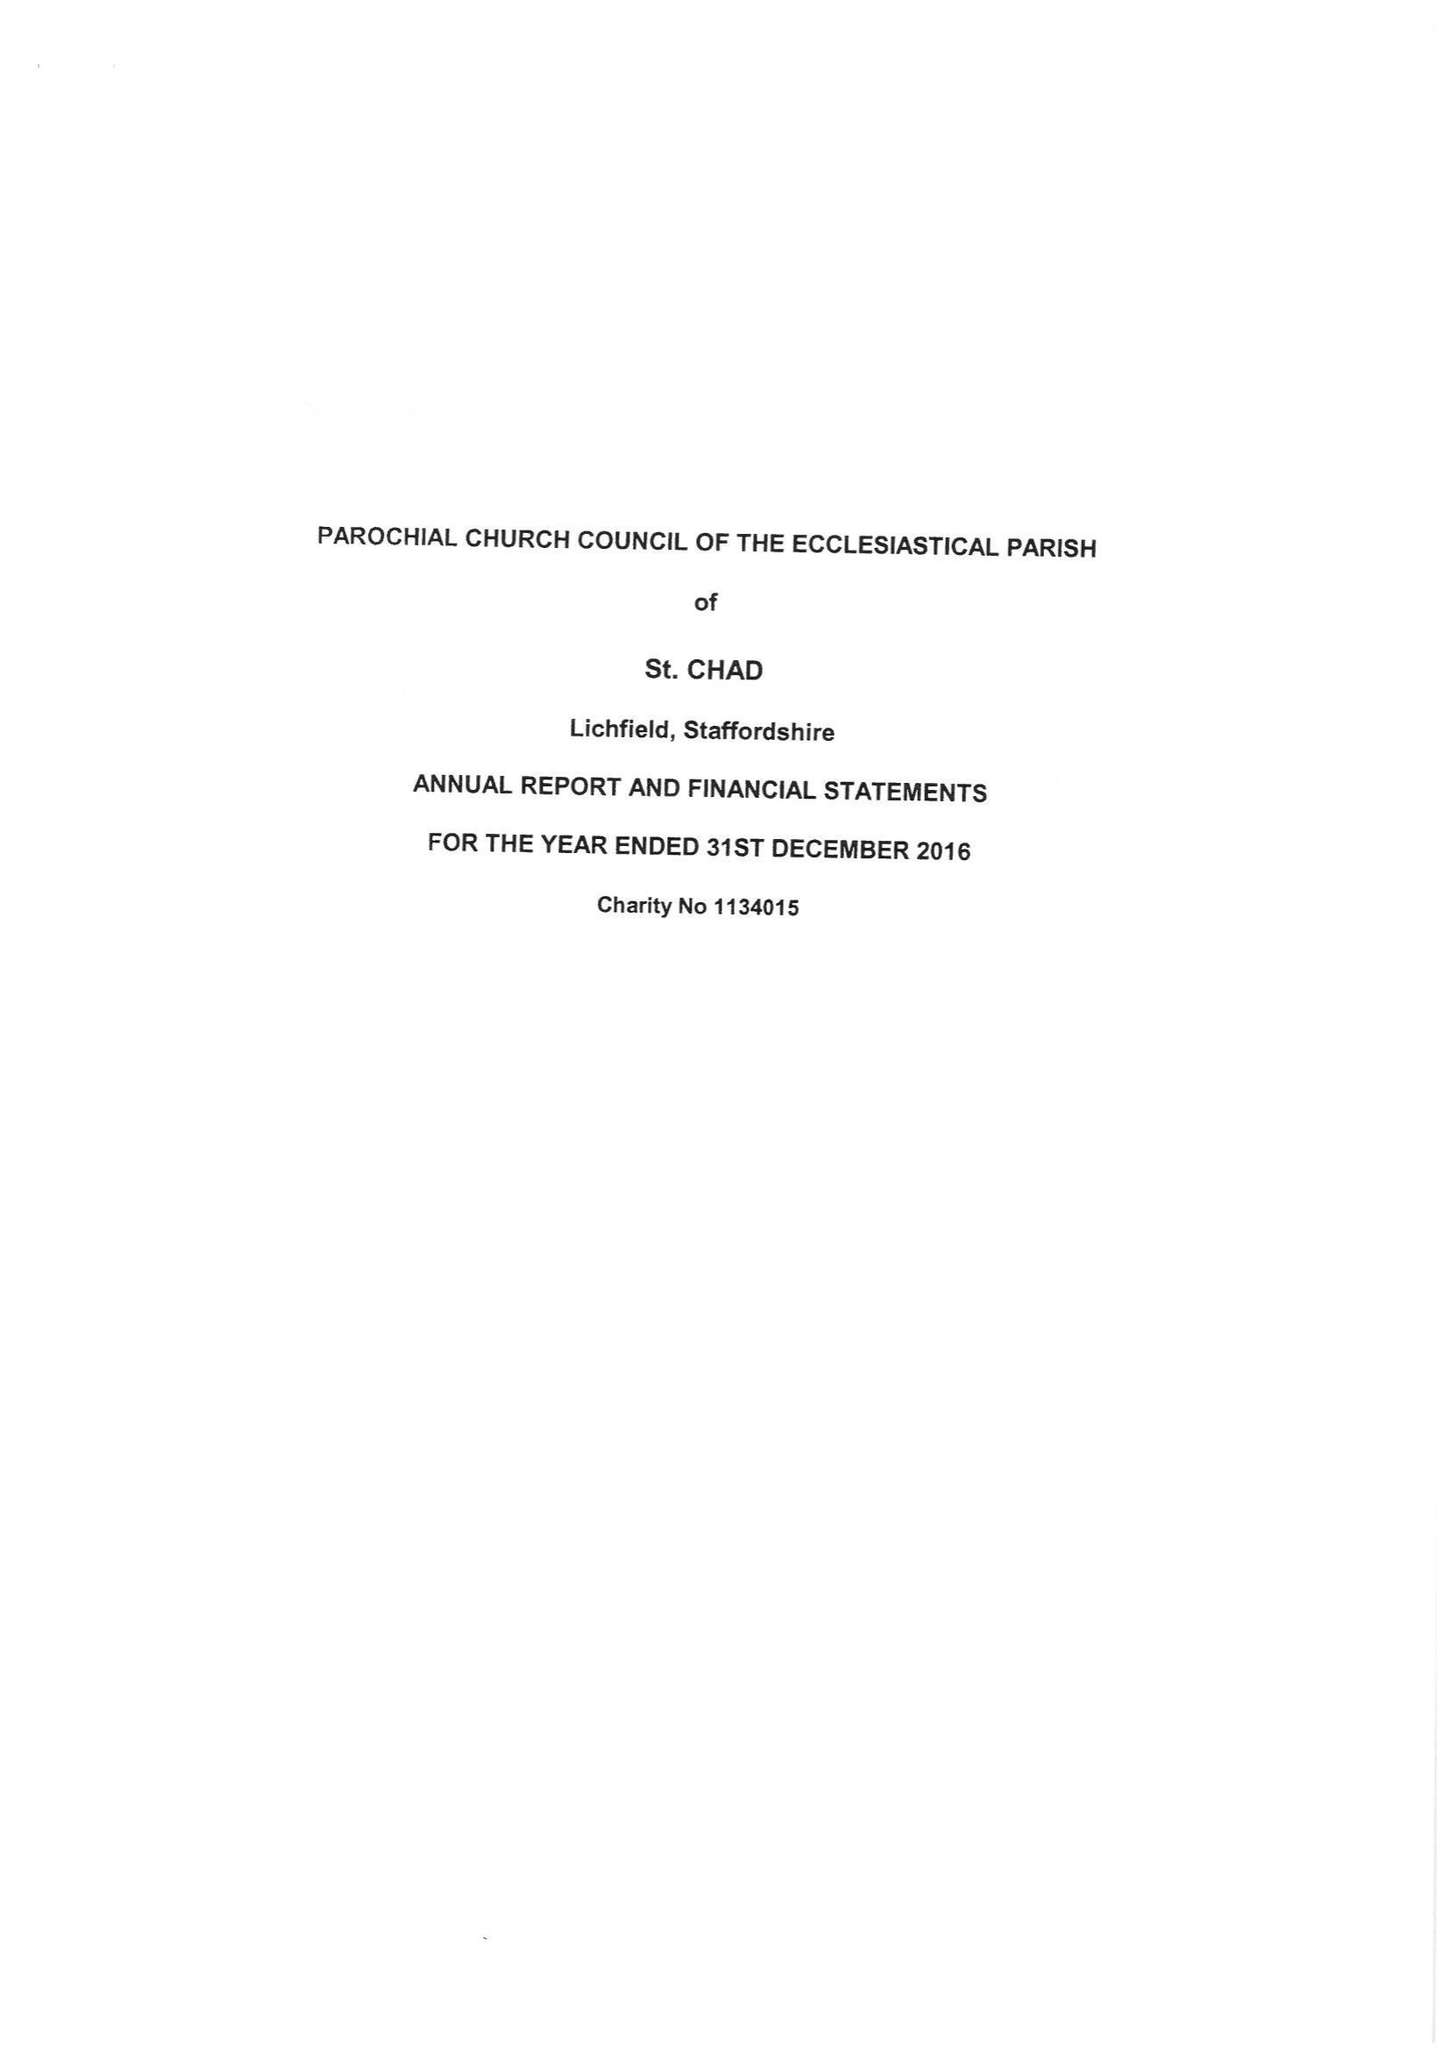What is the value for the address__postcode?
Answer the question using a single word or phrase. WS13 7LD 